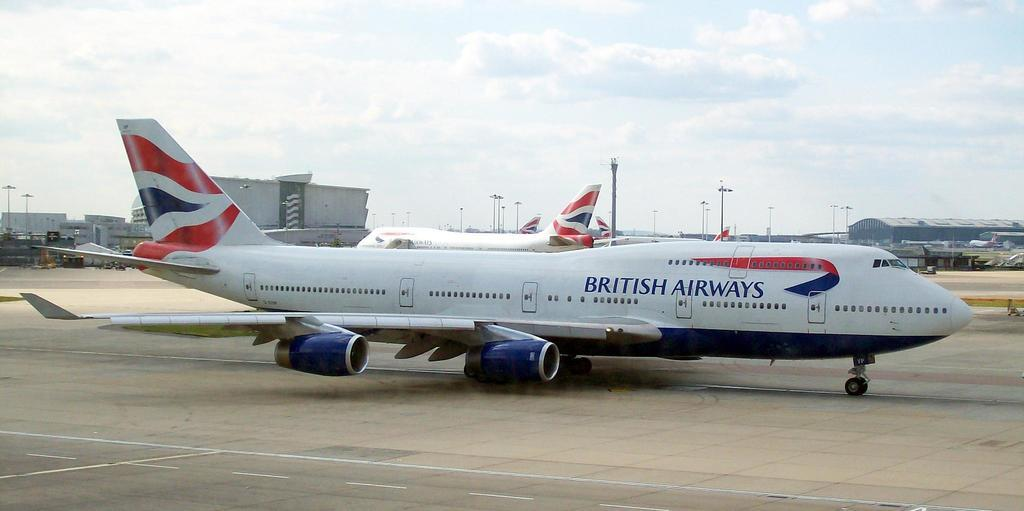<image>
Create a compact narrative representing the image presented. Almost half a dozen British Airways jets are positioned in various places across the airport tarmac. 